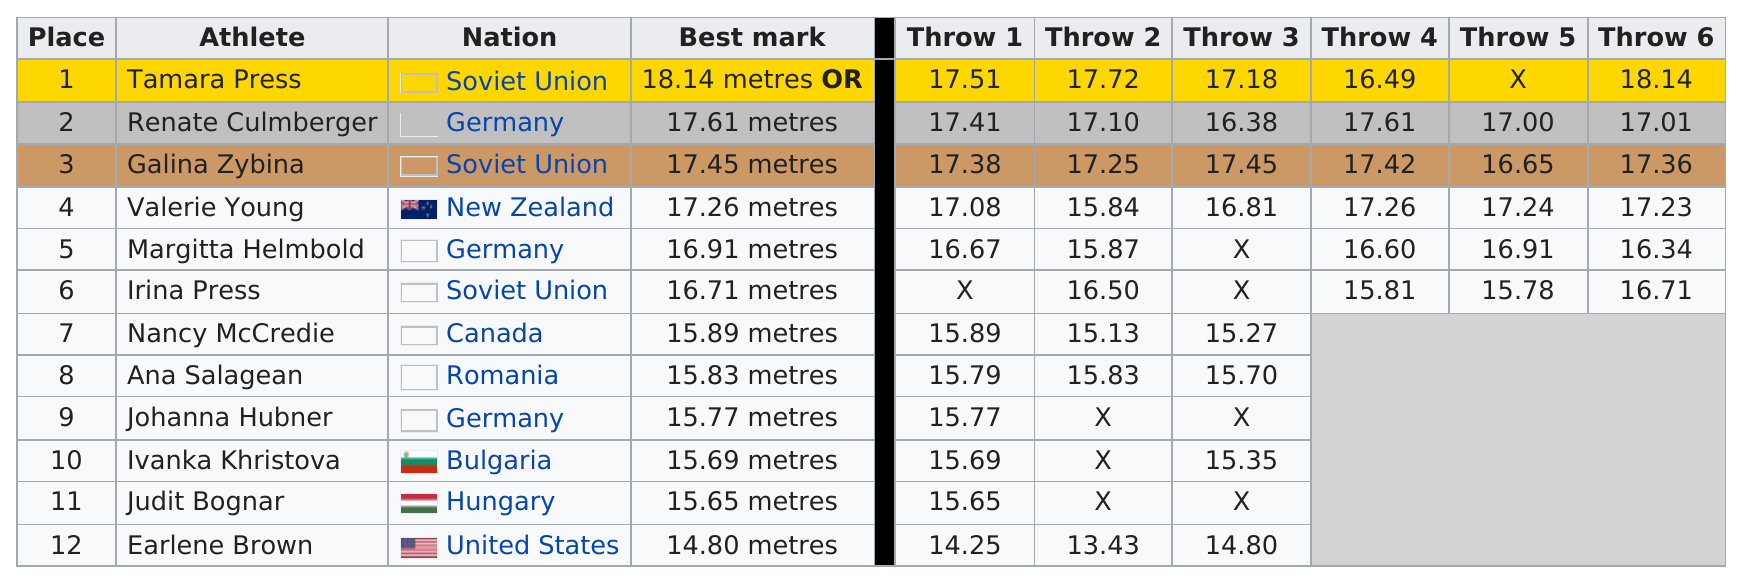Identify some key points in this picture. Tamara Press, an athlete, placed top. In this competition, a total of 3 athletes hailed from the Soviet Union. Valerie Young is the next athlete in line with the best mark after Galina Zybina. After Irina Press, Nancy McCredie placed next. The last recorded throw for Valerie Young was 17.23 meters. 